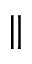Convert formula to latex. <formula><loc_0><loc_0><loc_500><loc_500>\|</formula> 